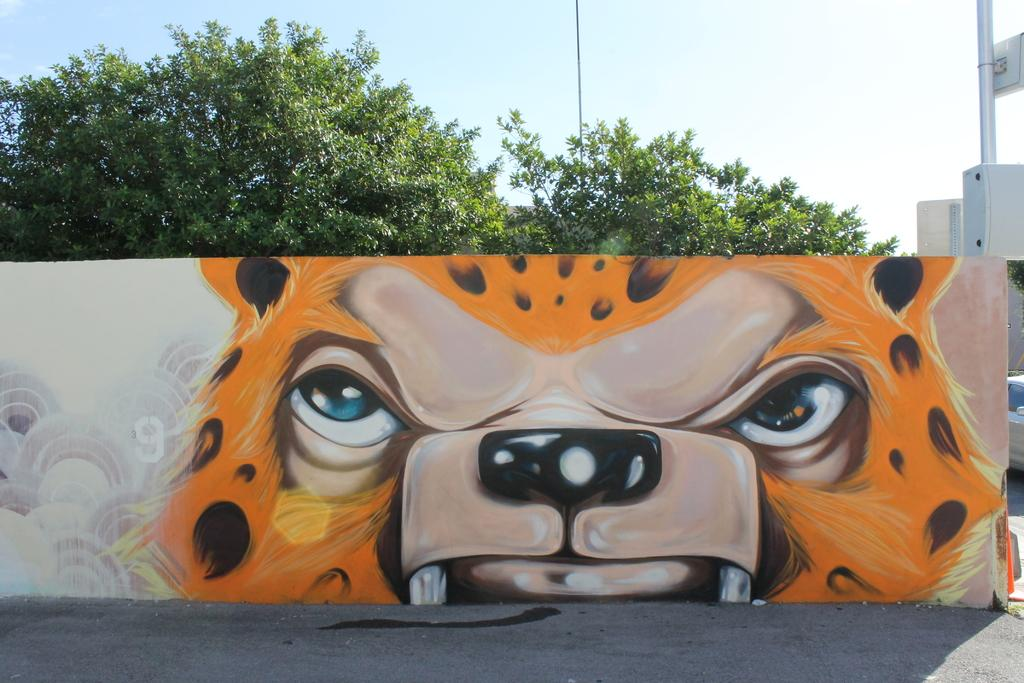What is hanging on the wall in the image? There is a painting on the wall. What type of natural elements can be seen in the image? There are trees in the image. What structures are present in the image? There are poles and a board in the image. What can be seen in the background of the image? The sky is visible in the background of the image. What type of jelly is being served on the sofa in the image? There is no sofa or jelly present in the image. What role does the governor play in the image? There is no governor or any political figure mentioned in the image. 